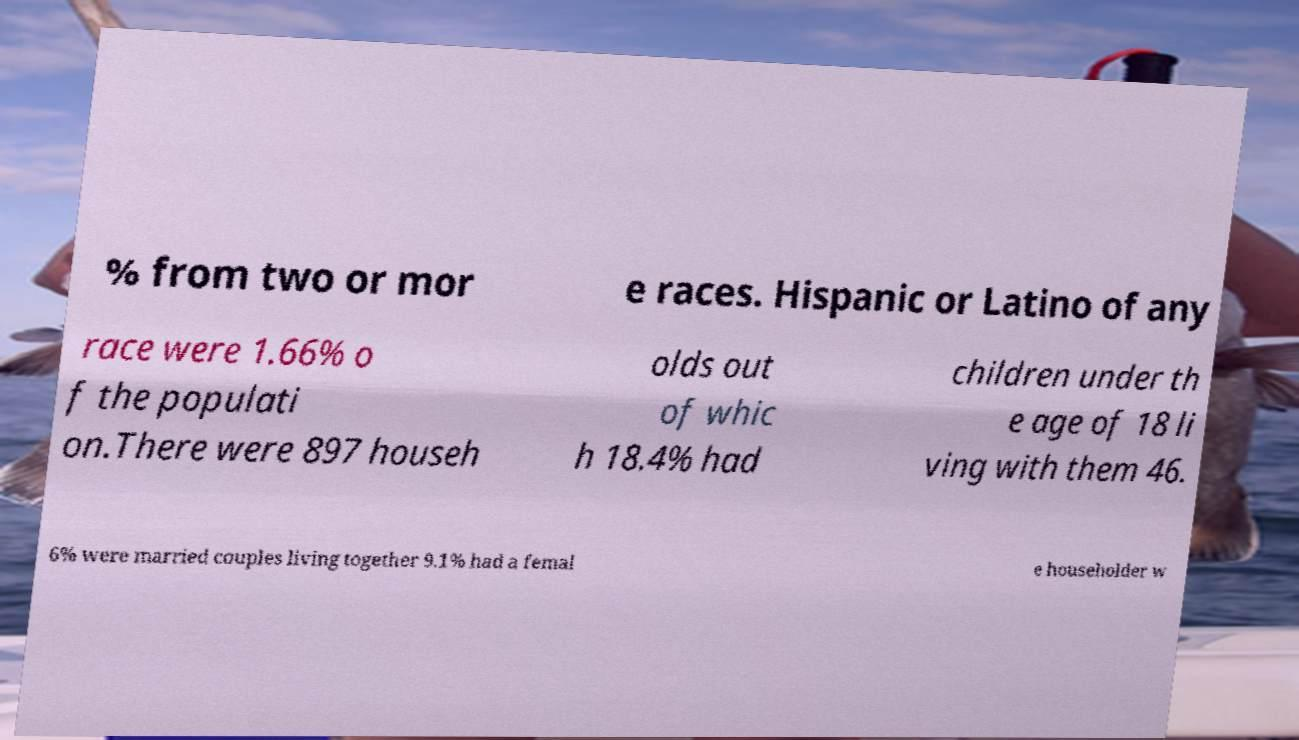Could you extract and type out the text from this image? % from two or mor e races. Hispanic or Latino of any race were 1.66% o f the populati on.There were 897 househ olds out of whic h 18.4% had children under th e age of 18 li ving with them 46. 6% were married couples living together 9.1% had a femal e householder w 